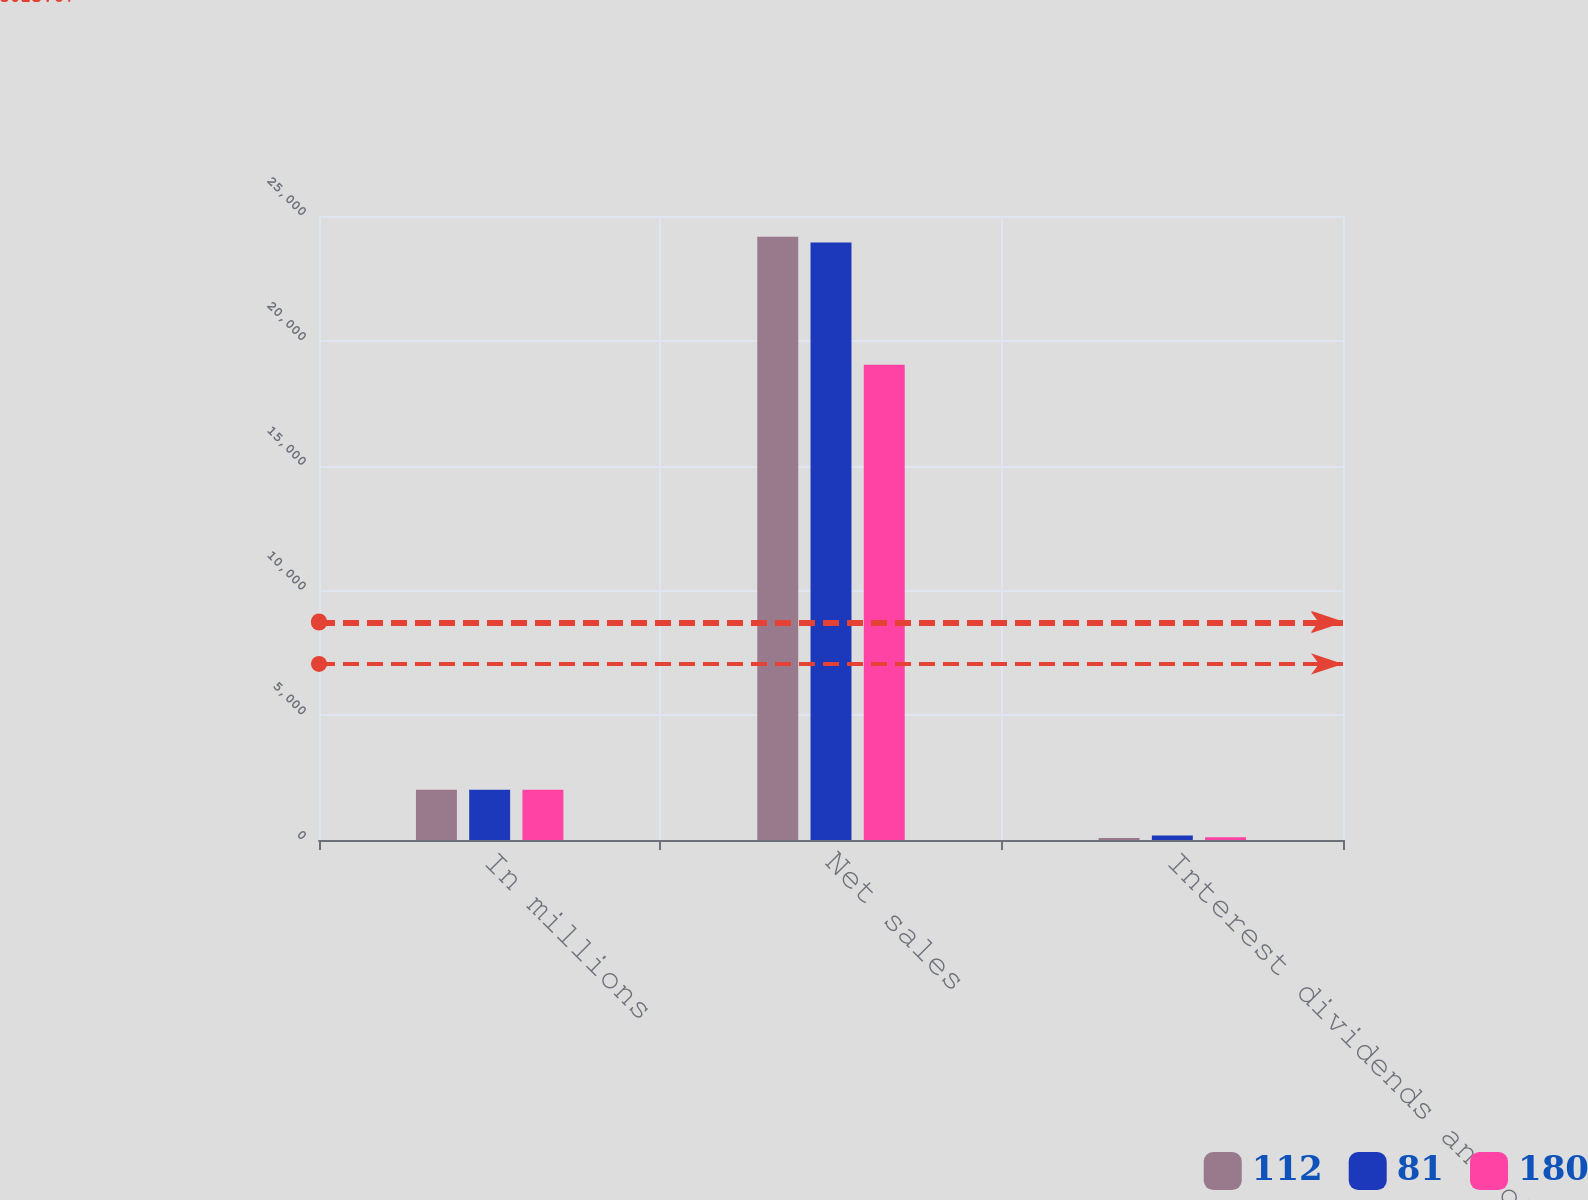Convert chart. <chart><loc_0><loc_0><loc_500><loc_500><stacked_bar_chart><ecel><fcel>In millions<fcel>Net sales<fcel>Interest dividends and other<nl><fcel>112<fcel>2012<fcel>24172<fcel>81<nl><fcel>81<fcel>2011<fcel>23939<fcel>180<nl><fcel>180<fcel>2010<fcel>19045<fcel>112<nl></chart> 